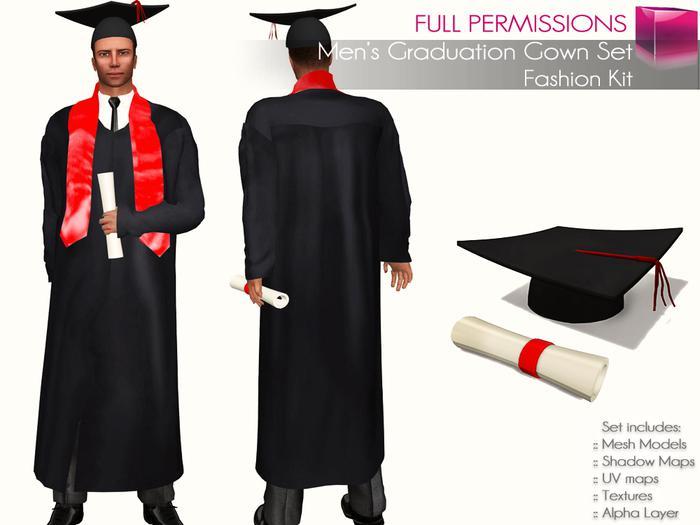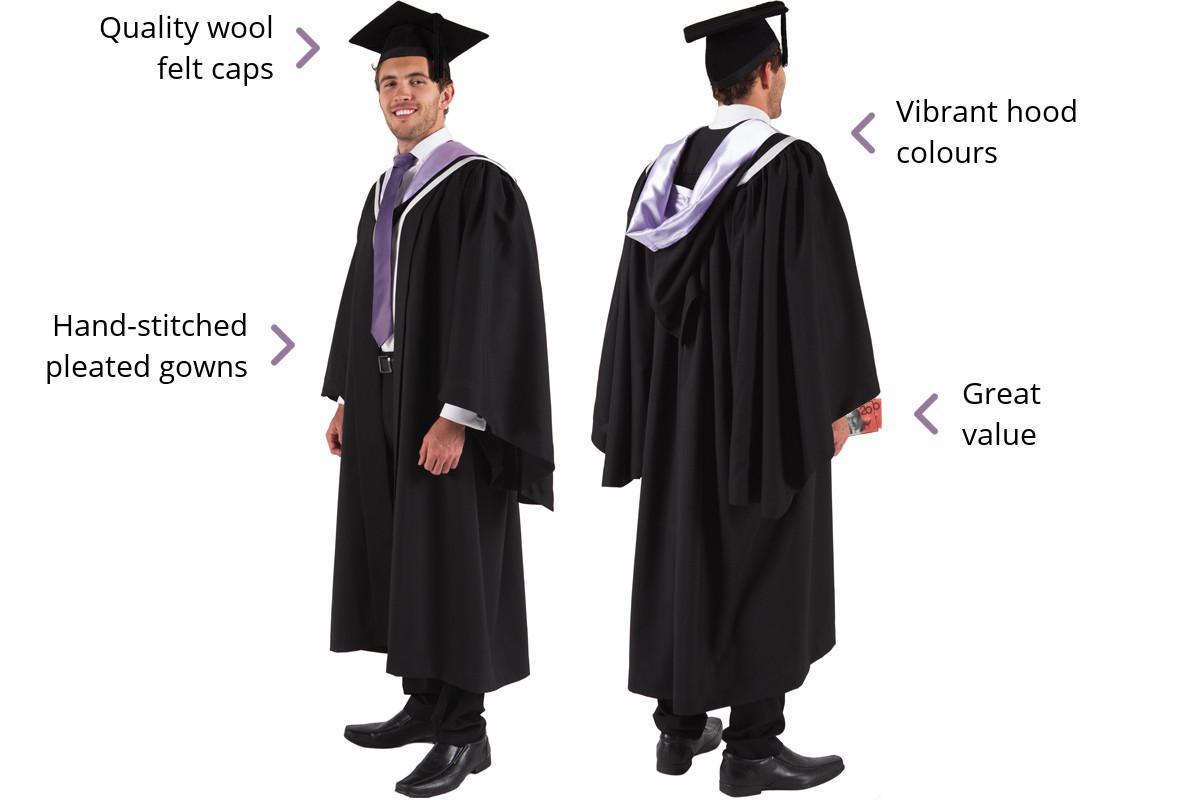The first image is the image on the left, the second image is the image on the right. Examine the images to the left and right. Is the description "There is a women in one of the images." accurate? Answer yes or no. No. The first image is the image on the left, the second image is the image on the right. Evaluate the accuracy of this statement regarding the images: "In one image, the gown is accessorized with a red scarf worn around the neck, hanging open at the waist.". Is it true? Answer yes or no. Yes. 